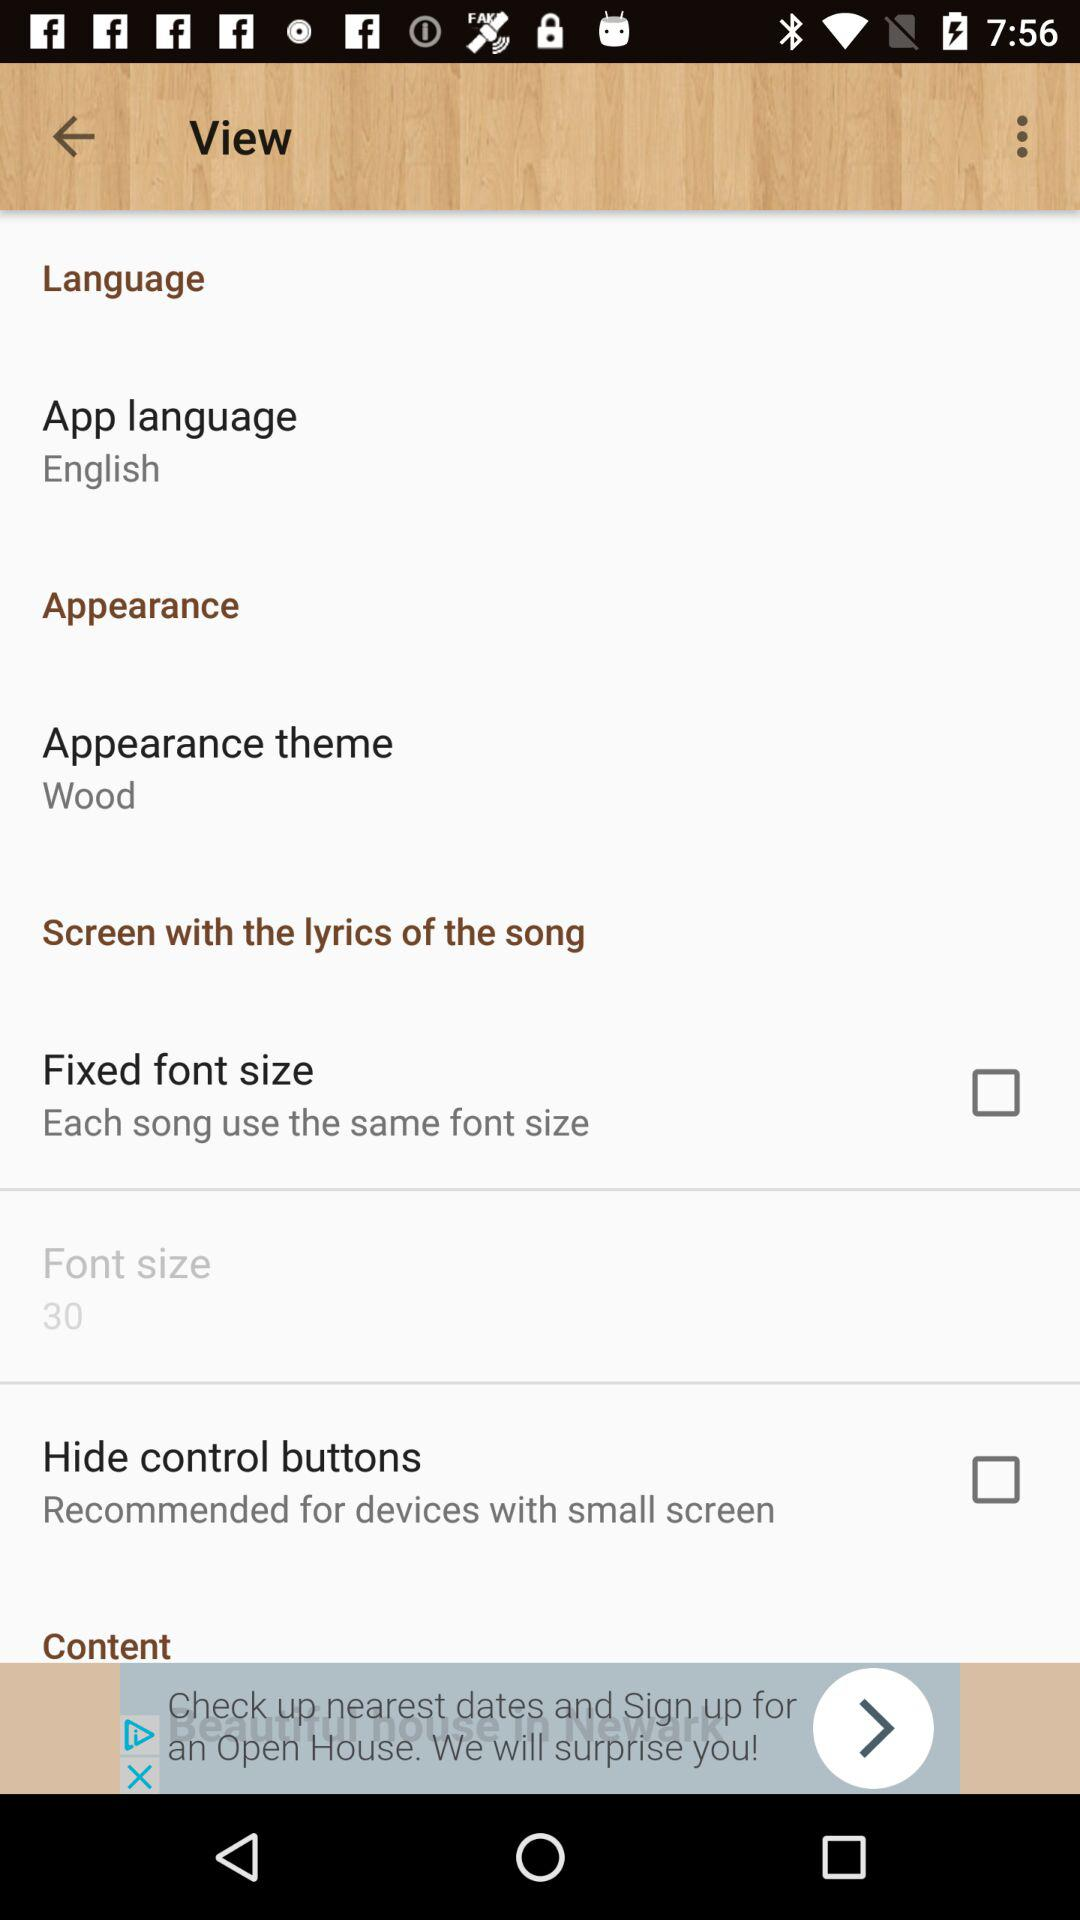What is the status of "Hide control buttons"? The status is "off". 